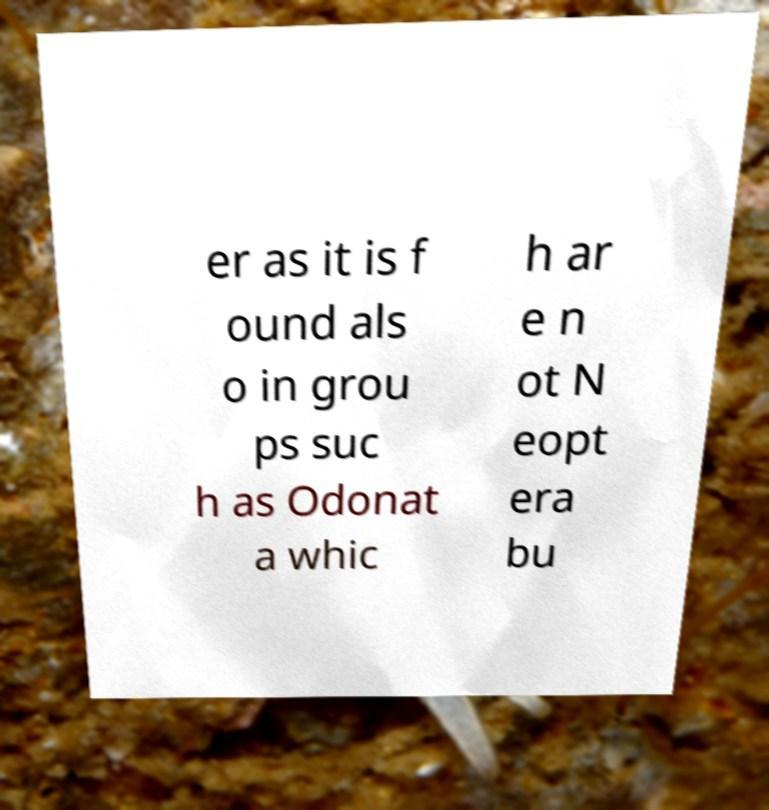Could you assist in decoding the text presented in this image and type it out clearly? er as it is f ound als o in grou ps suc h as Odonat a whic h ar e n ot N eopt era bu 